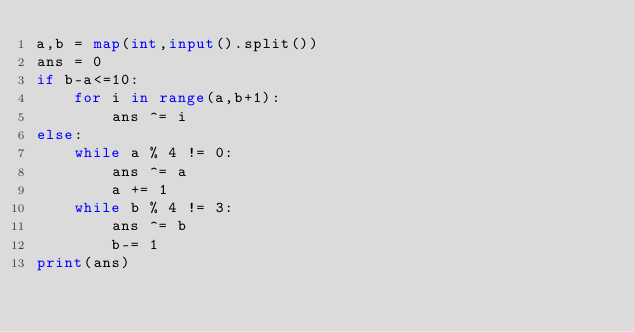<code> <loc_0><loc_0><loc_500><loc_500><_Python_>a,b = map(int,input().split())
ans = 0
if b-a<=10:
    for i in range(a,b+1):
        ans ^= i
else:
    while a % 4 != 0:
        ans ^= a
        a += 1
    while b % 4 != 3:
        ans ^= b
        b-= 1
print(ans)</code> 